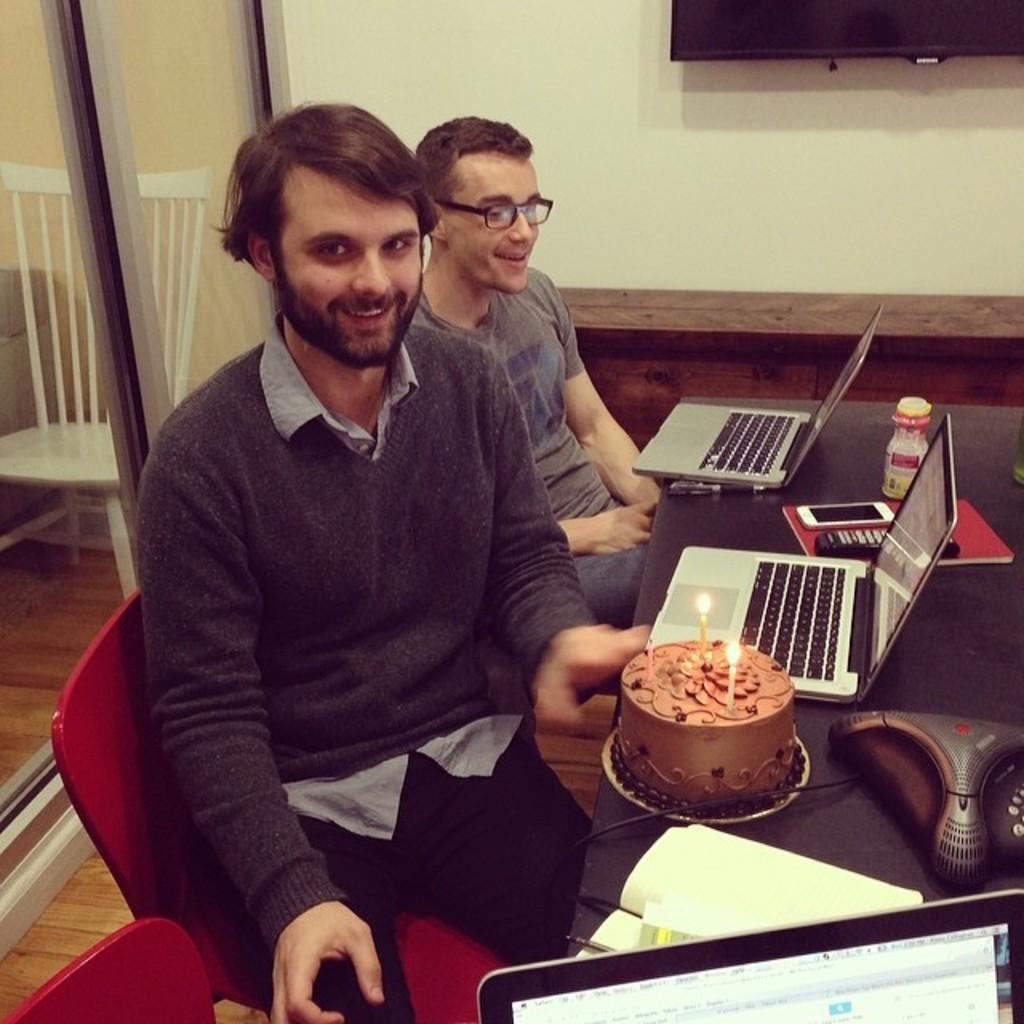How many people are in the image? There are two men in the image. What are the men doing in the image? The men are sitting in chairs and at a table. What objects can be seen on the table? There are laptops and other electronic gadgets on the table. What is the man holding in the image? One man is holding a cake. What type of pie is being served on the table in the image? There is no pie present in the image; it features a cake being held by one of the men. Can you see a pipe on the table in the image? There is no pipe present in the image; the table contains laptops, electronic gadgets, and a cake. 